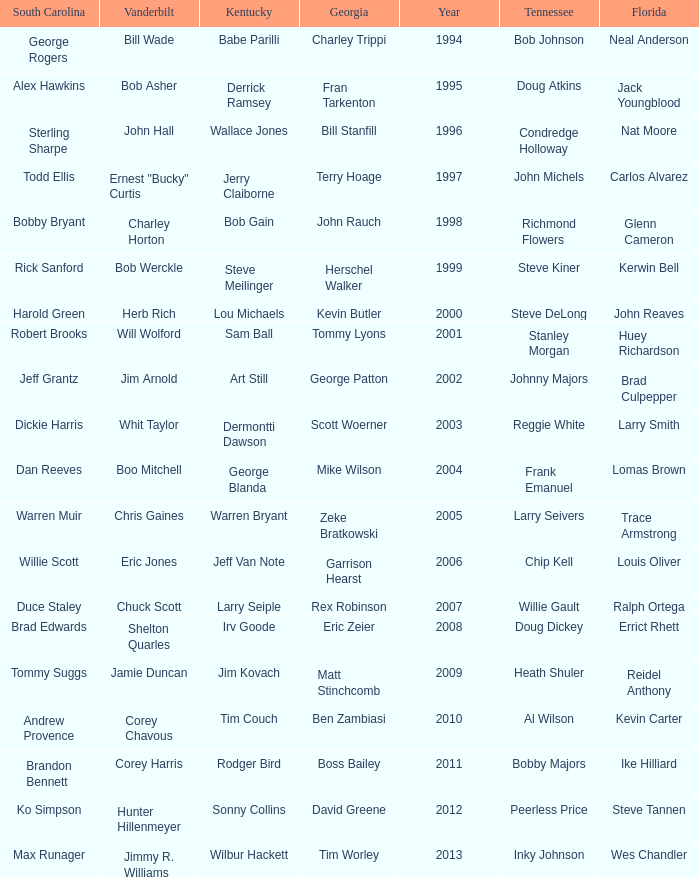What is the total Year of jeff van note ( Kentucky) 2006.0. 